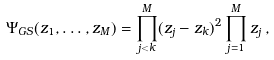Convert formula to latex. <formula><loc_0><loc_0><loc_500><loc_500>\Psi _ { G S } ( z _ { 1 } , \dots , z _ { M } ) = \prod _ { j < k } ^ { M } ( z _ { j } - z _ { k } ) ^ { 2 } \prod _ { j = 1 } ^ { M } z _ { j } \, ,</formula> 